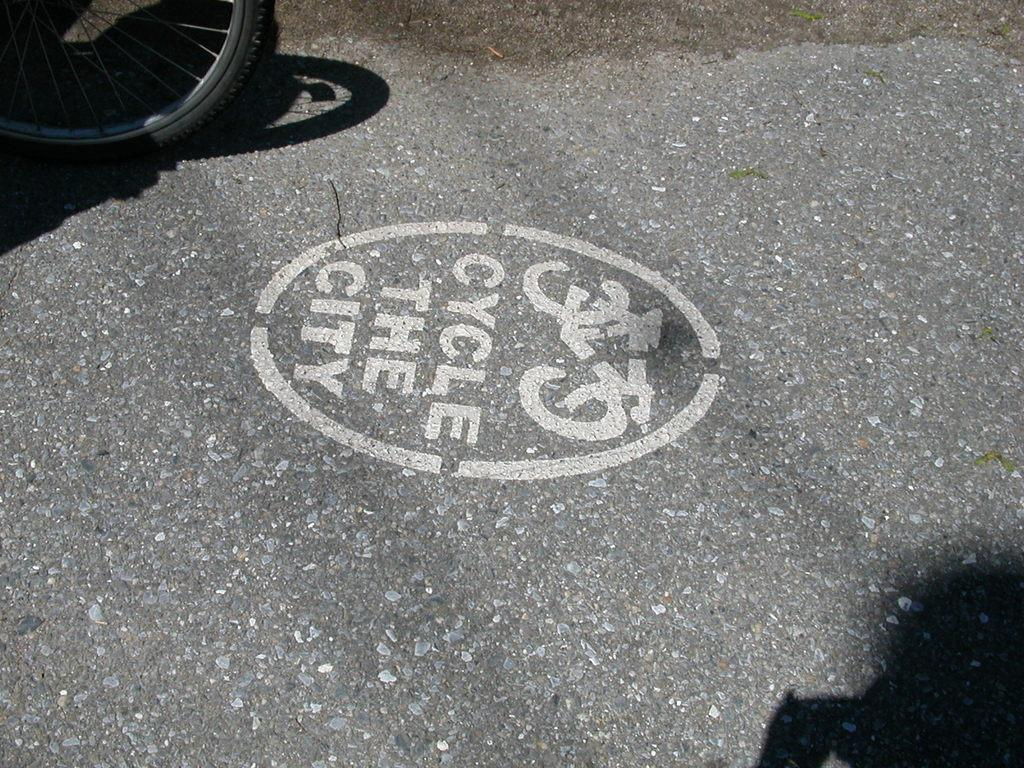What can be seen in the top left side of the image? There is a wheel in the top left side of the image. What phrase is written on the floor in the image? The phrase "cycle the city" is written on the floor. Where is the flock of birds in the image? There is no flock of birds present in the image. What verse can be found in the image? There is no verse present in the image; only the phrase "cycle the city" is written on the floor. 